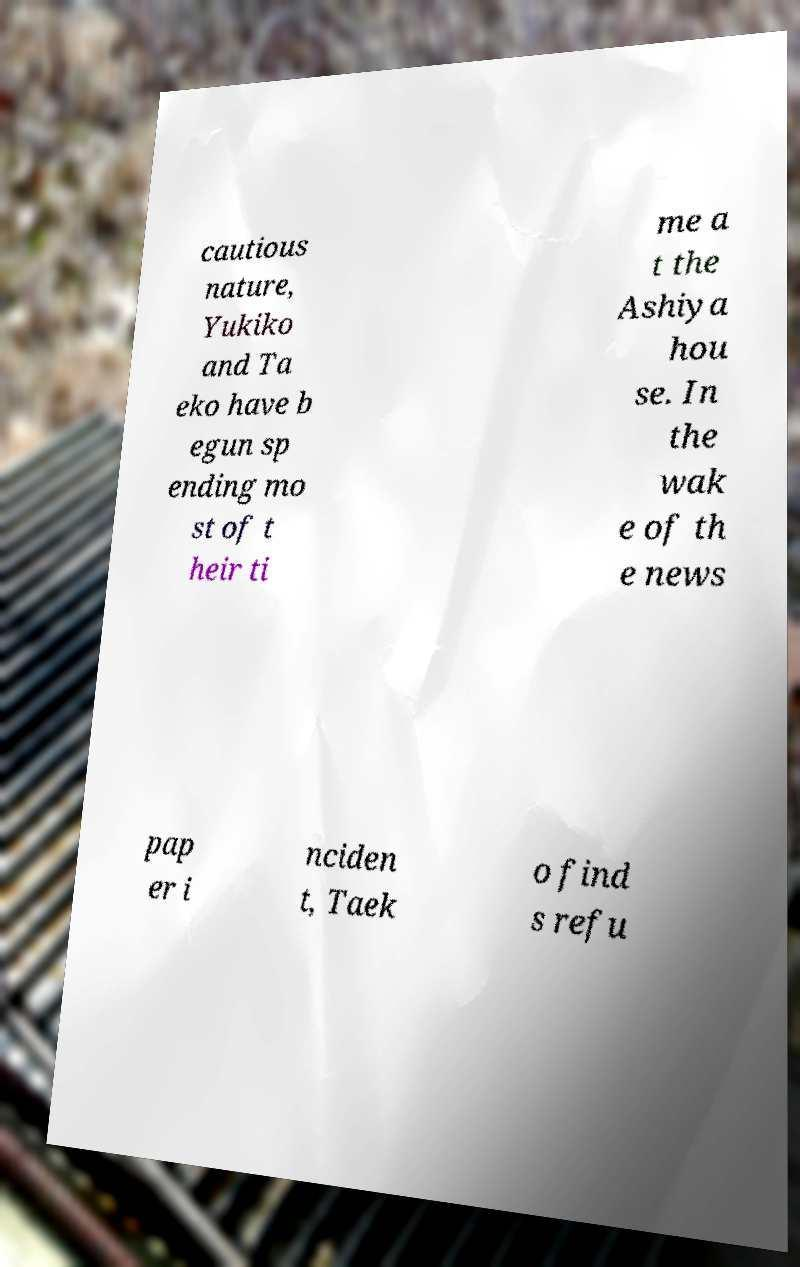Please read and relay the text visible in this image. What does it say? cautious nature, Yukiko and Ta eko have b egun sp ending mo st of t heir ti me a t the Ashiya hou se. In the wak e of th e news pap er i nciden t, Taek o find s refu 